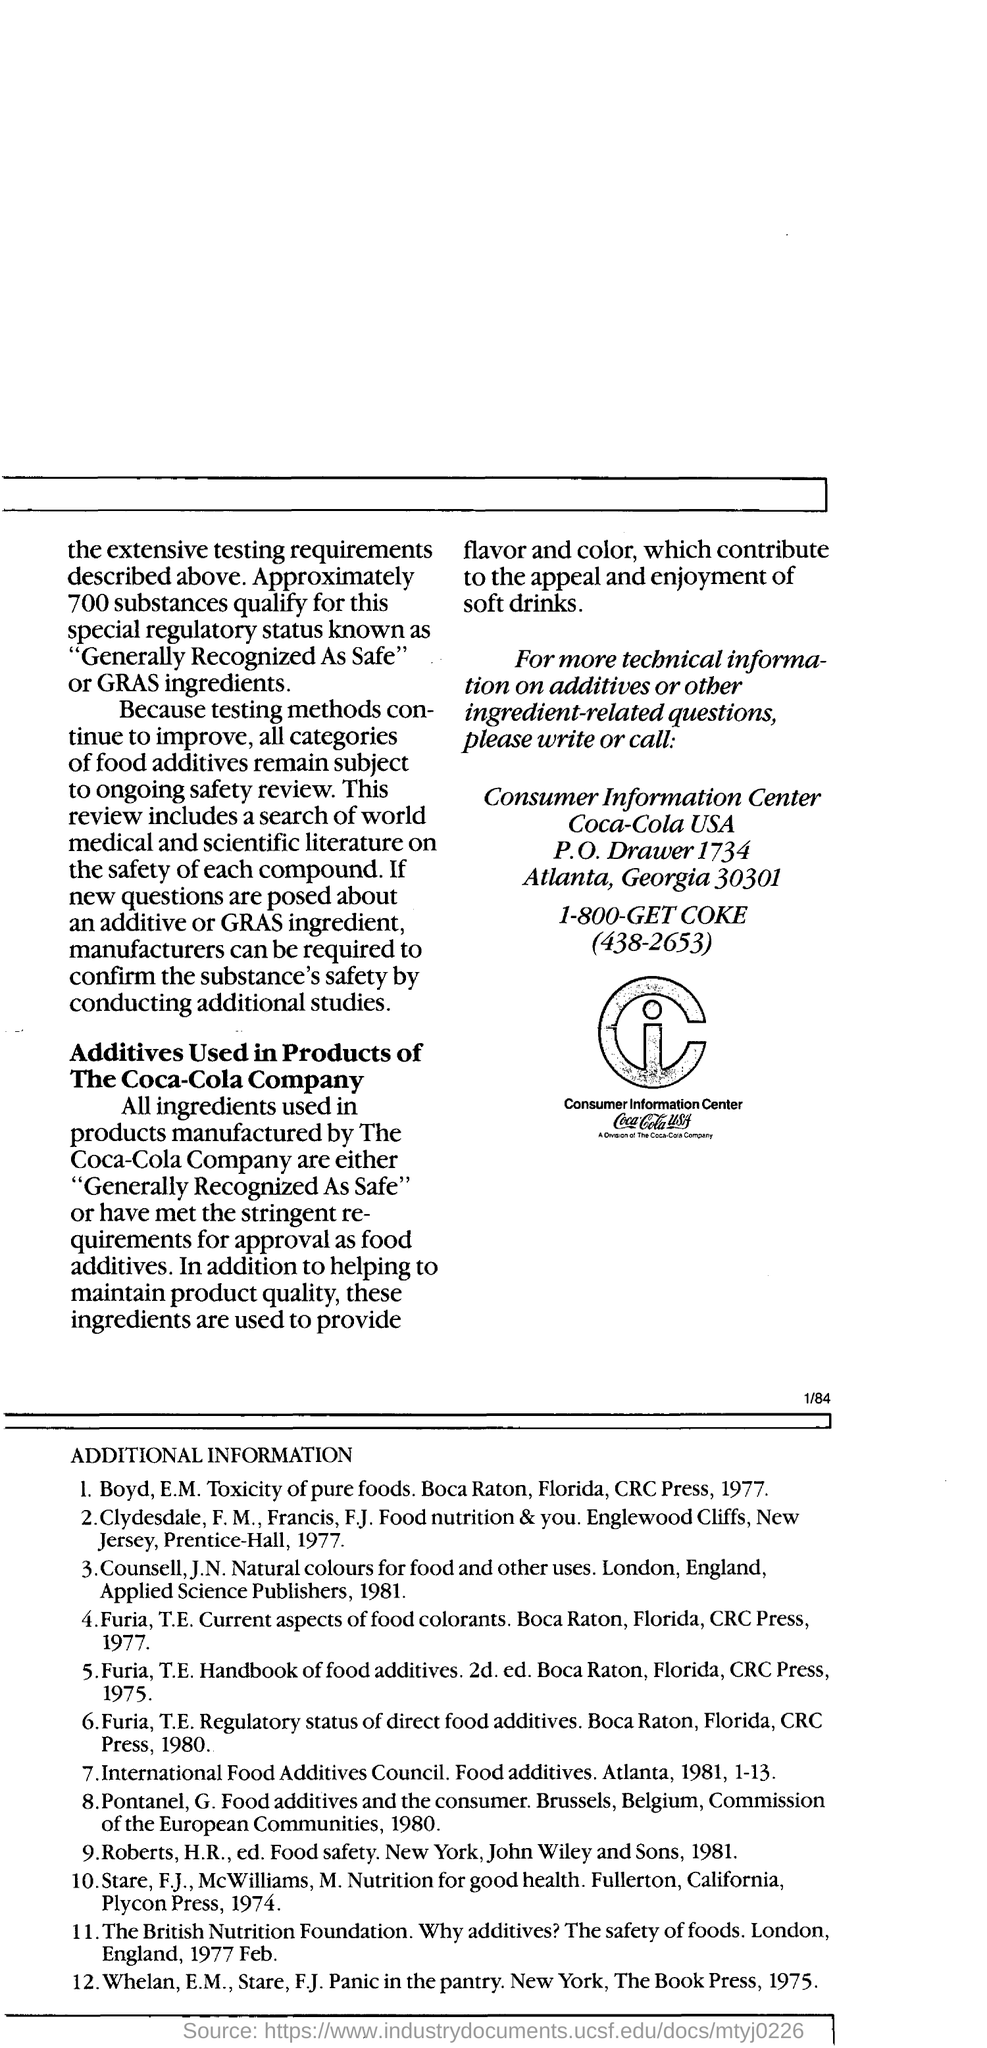Coca-cola consumer information is located in which country ?
Your answer should be very brief. USA. IN which state consumer information centre located?
Your response must be concise. Georgia. 